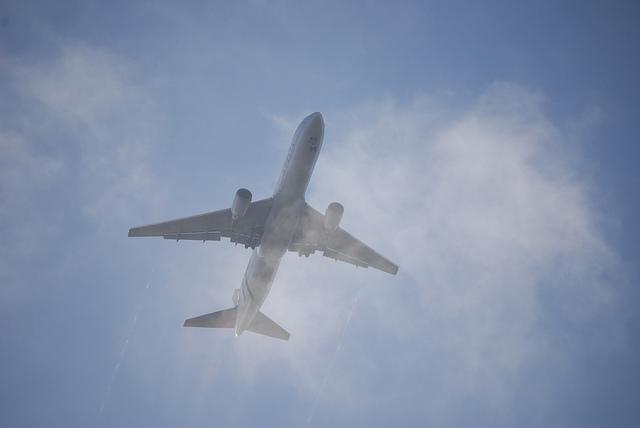How many glasses are holding orange juice?
Give a very brief answer. 0. 